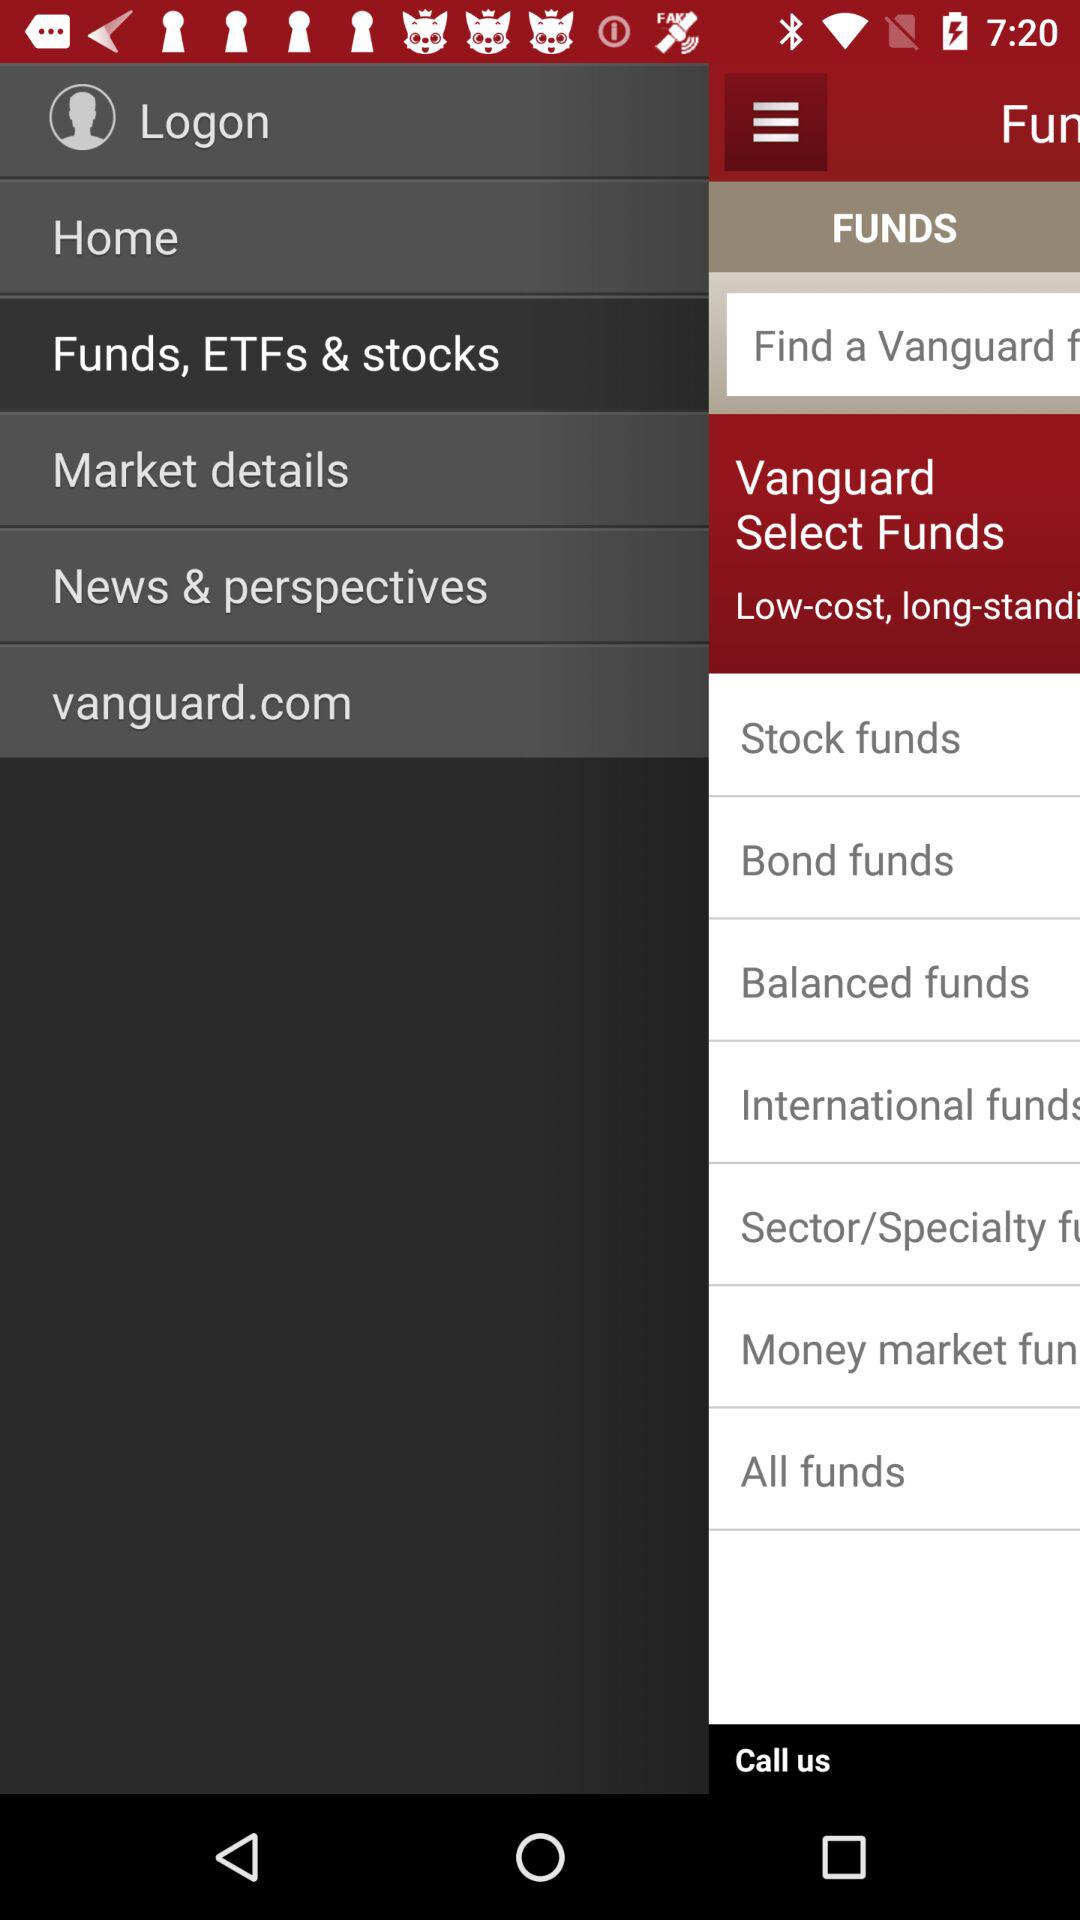What is the web address? The web address is vanguard.com. 